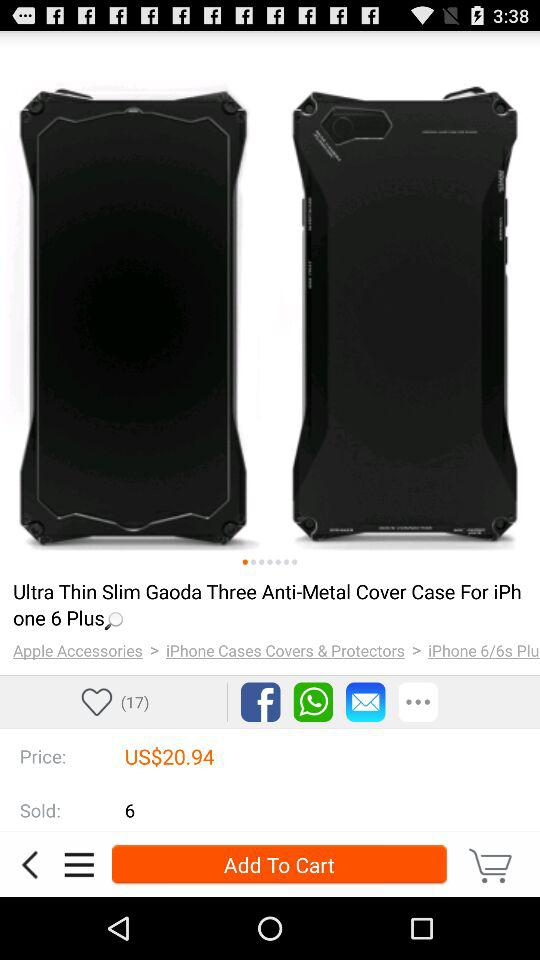How many likes are there on the product? There are 17 likes on the product. 